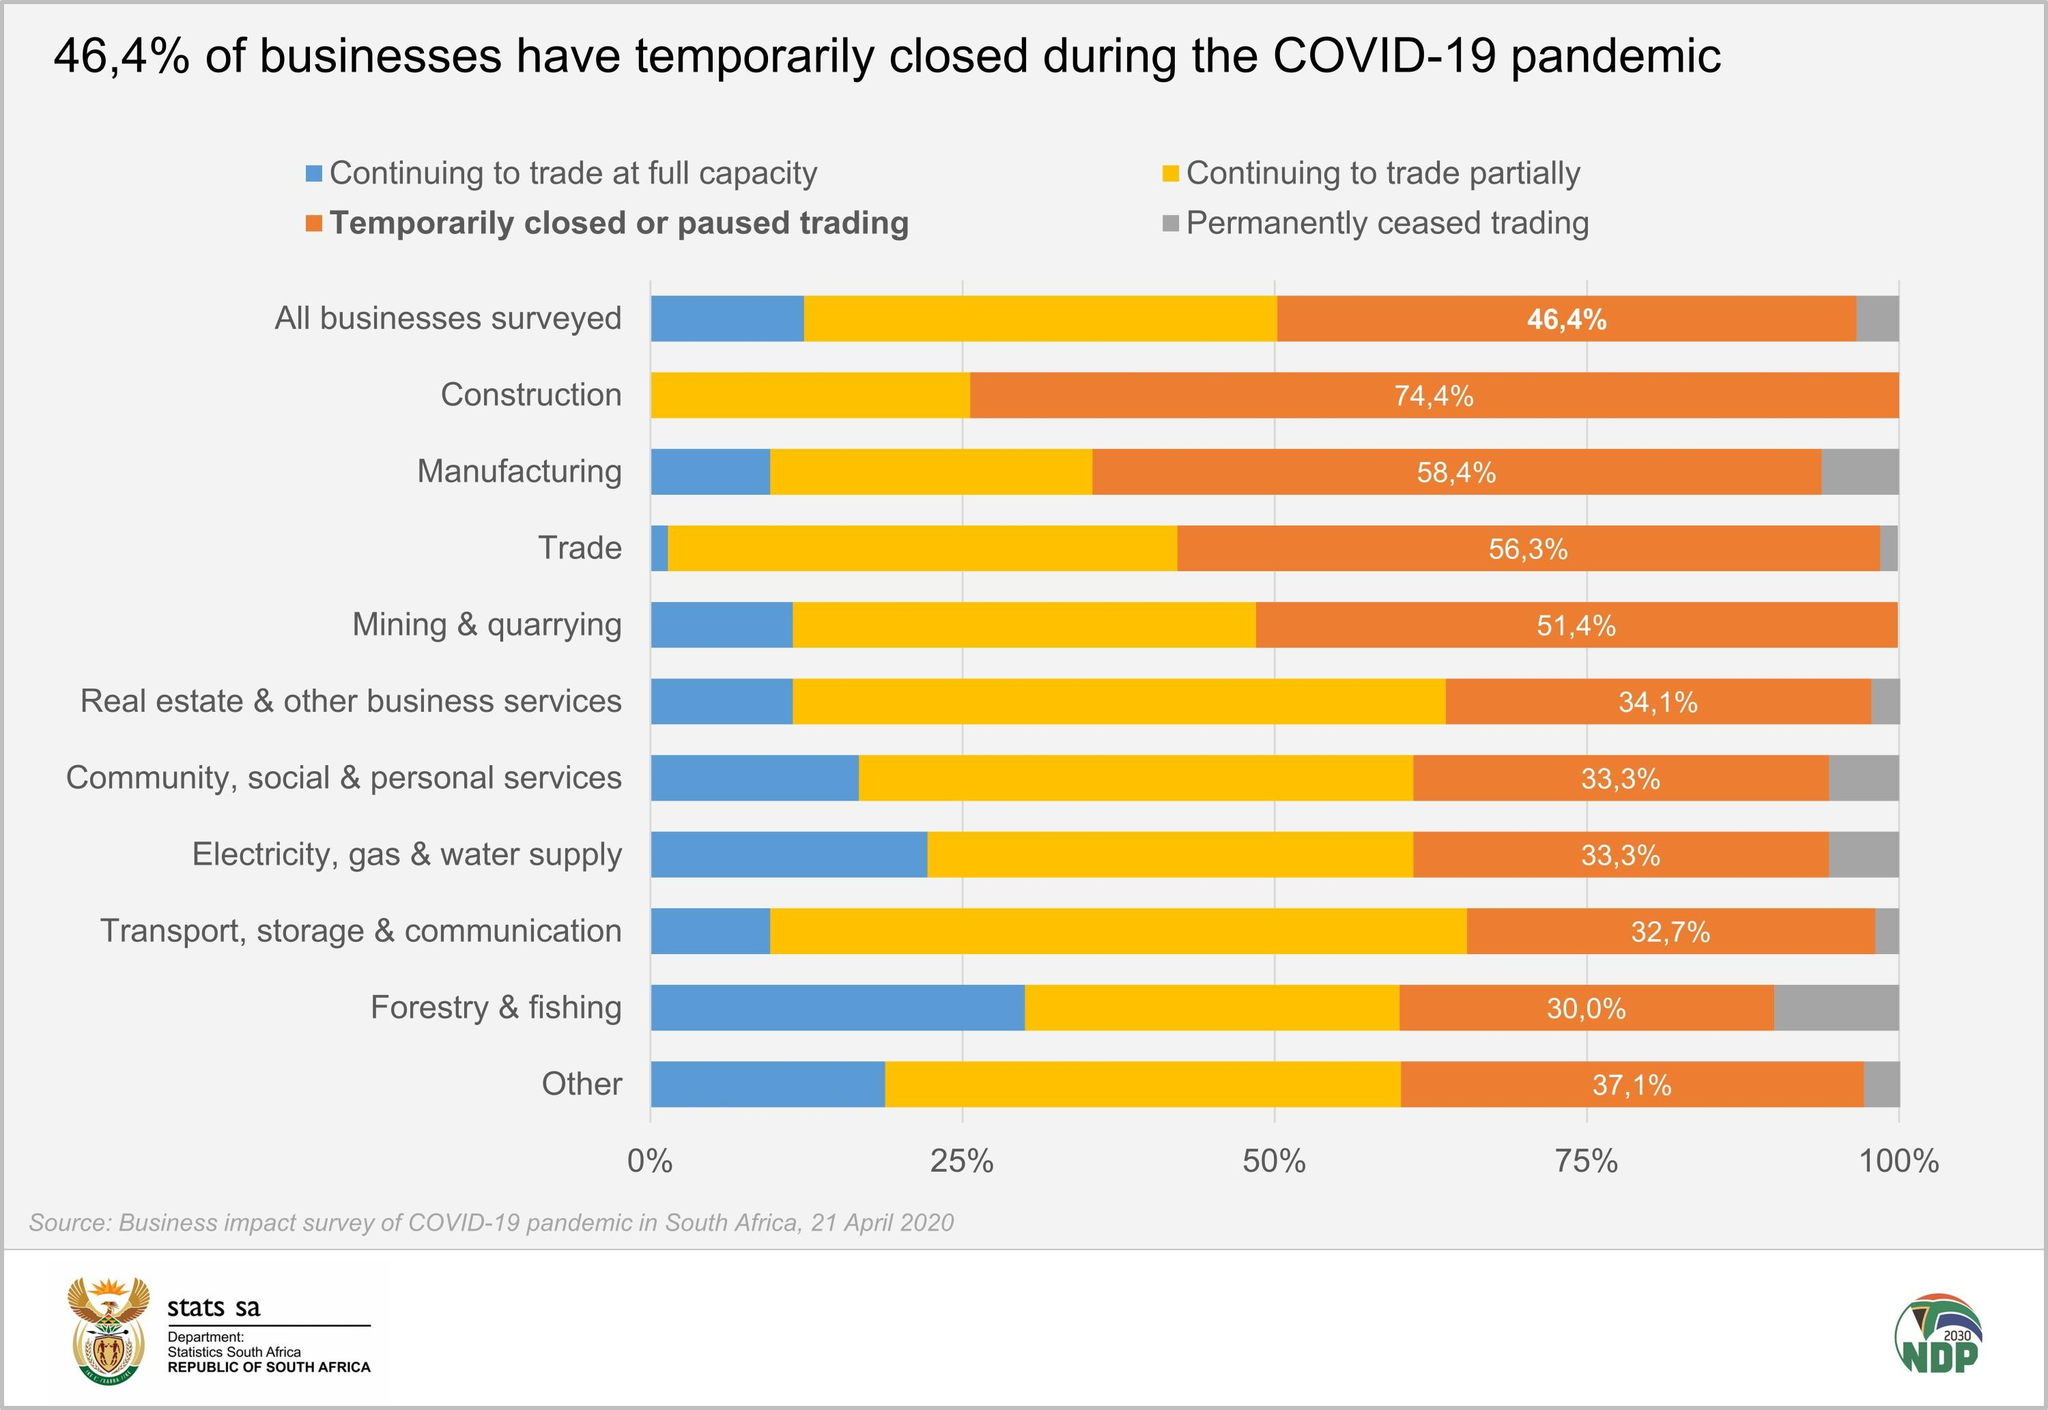Point out several critical features in this image. The business that has been the least impacted by temporary or permanent closure is transport, storage, and communication. According to the data, 48.6% of mining and quarrying businesses are currently operating at full capacity or partially. There are businesses in the construction, mining, and quarrying industries that have not permanently ceased trading. According to the data, approximately 25.6% of the construction businesses that experienced financial difficulty during the economic downturn continue to trade partially. Trading at full capacity continues to be shown in blue, indicating a strong level of activity. 